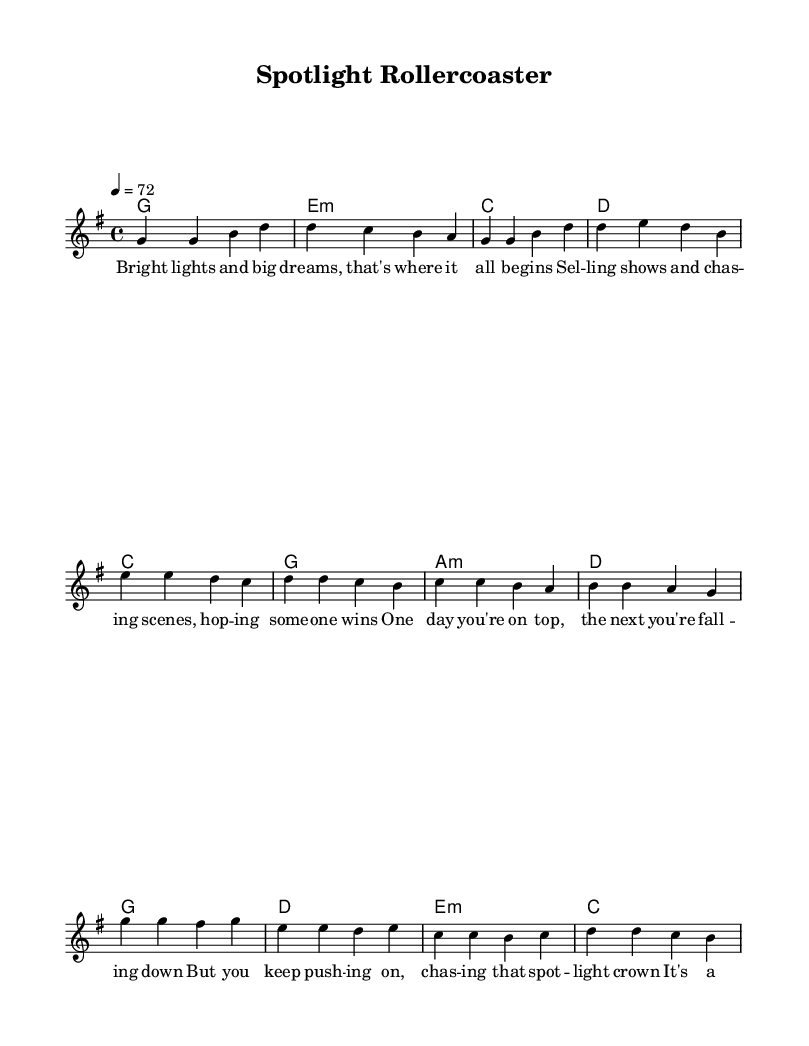What is the key signature of this music? The key signature is G major, indicated by one sharp (F#). This can be identified visually at the beginning of the staff where the sharps are noted.
Answer: G major What is the time signature of this music? The time signature is 4/4, which appears at the beginning of the notation and signifies four beats per measure.
Answer: 4/4 What is the tempo marking of this music? The tempo marking is 72 beats per minute, indicated by the "4 = 72" at the beginning of the piece. This means that a quarter note is equivalent to 72 beats per minute.
Answer: 72 How many measures are in the chorus? The chorus contains four measures, which is accounted by visually counting the groups of notes separated by bar lines in that section.
Answer: 4 What chord follows the E minor in the harmonies? The chord that follows the E minor (notated as e:m) in the harmonies is C major. You can derive this by looking at the chord progression in the harmonies section listed sequentially.
Answer: C What is the main theme of the lyrics? The main theme of the lyrics explores the ups and downs of a career in entertainment promotion, highlighting the struggles and moments of joy in this rollercoaster experience. This can be inferred from the content of the verses, pre-chorus, and chorus.
Answer: Ups and downs 